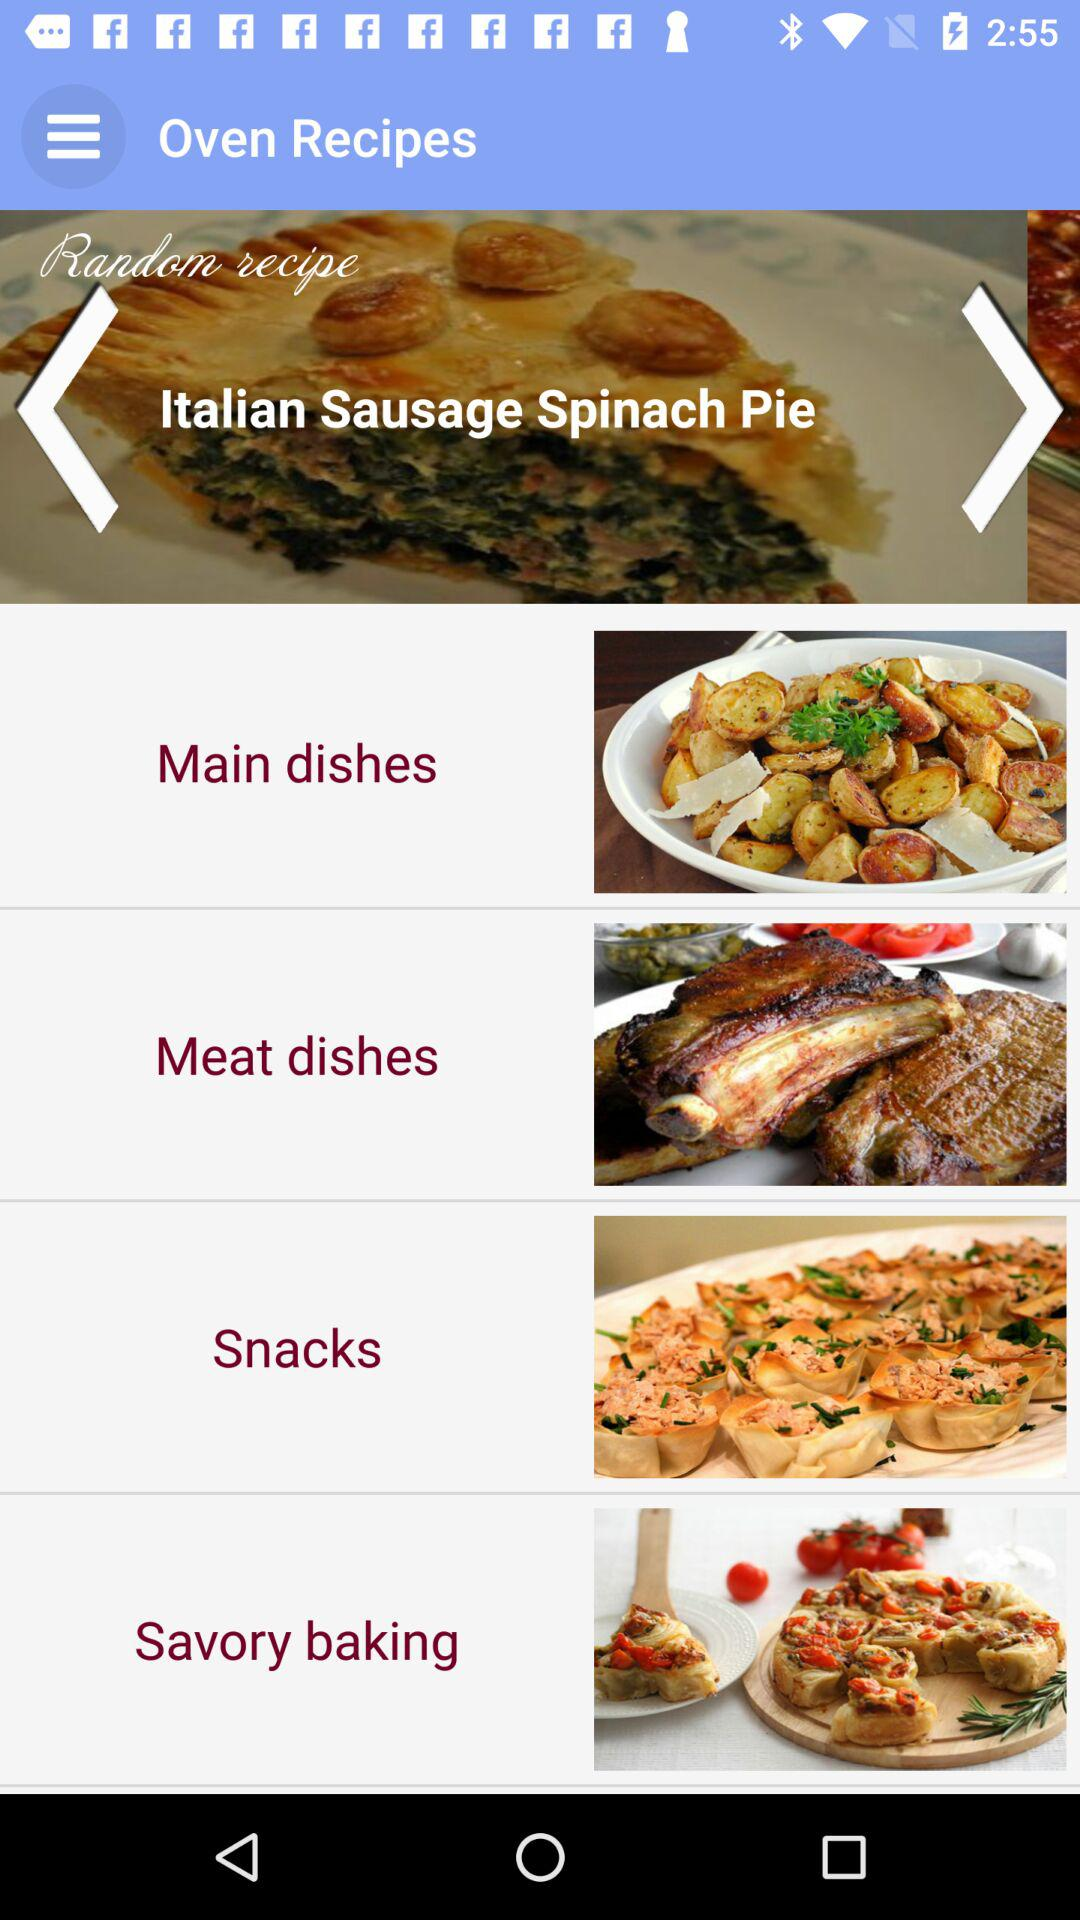What is the name of the recipe that is present in the random recipe? The name of the recipe is "Italian Sausage Spinach Pie". 